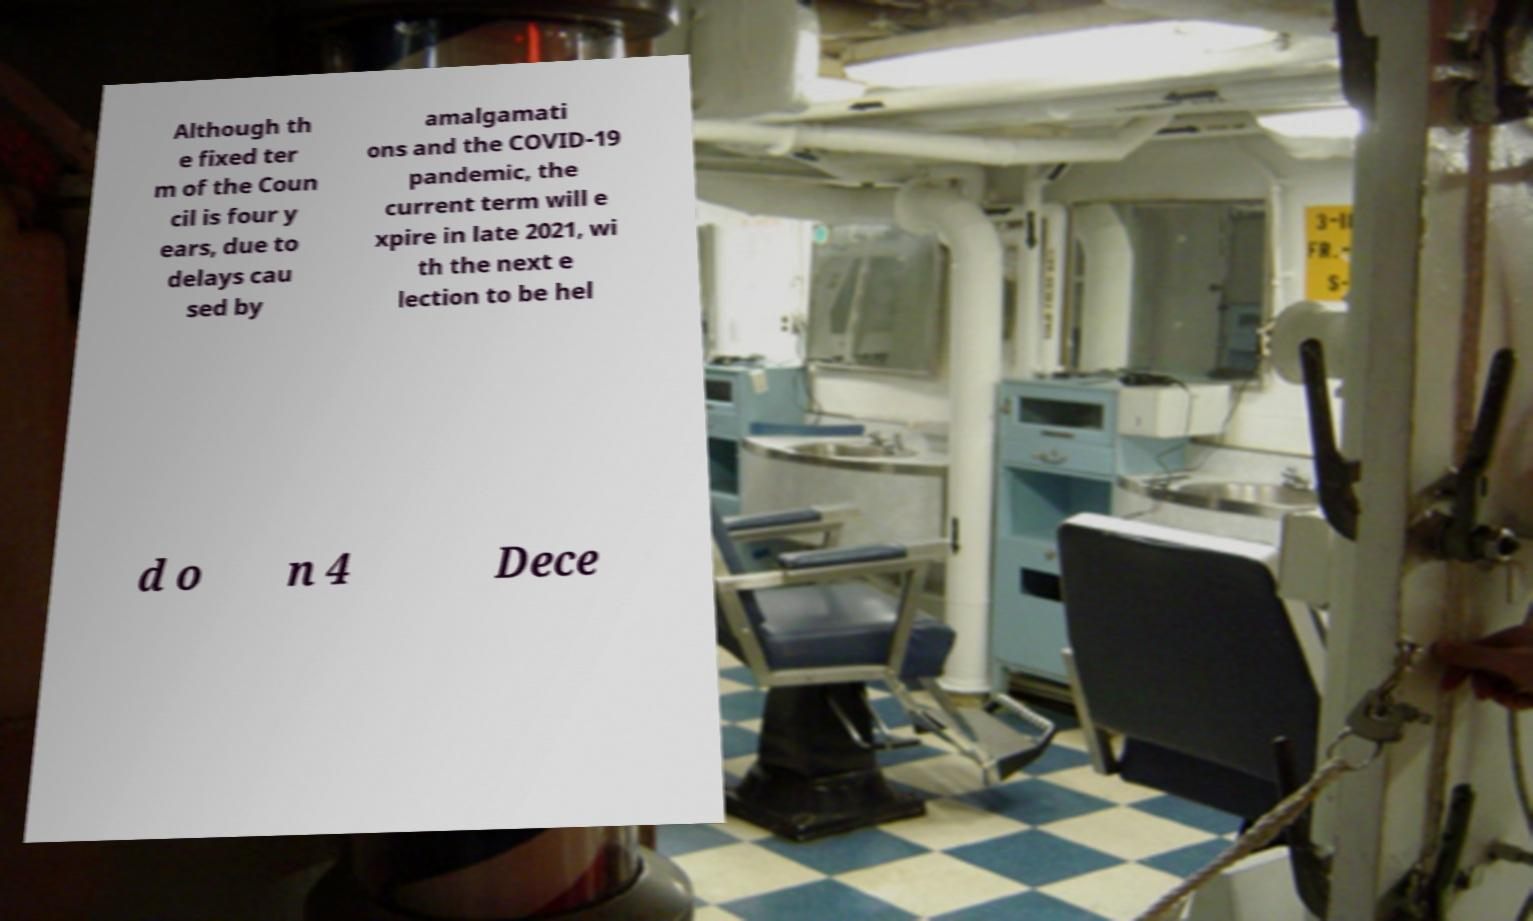Could you extract and type out the text from this image? Although th e fixed ter m of the Coun cil is four y ears, due to delays cau sed by amalgamati ons and the COVID-19 pandemic, the current term will e xpire in late 2021, wi th the next e lection to be hel d o n 4 Dece 